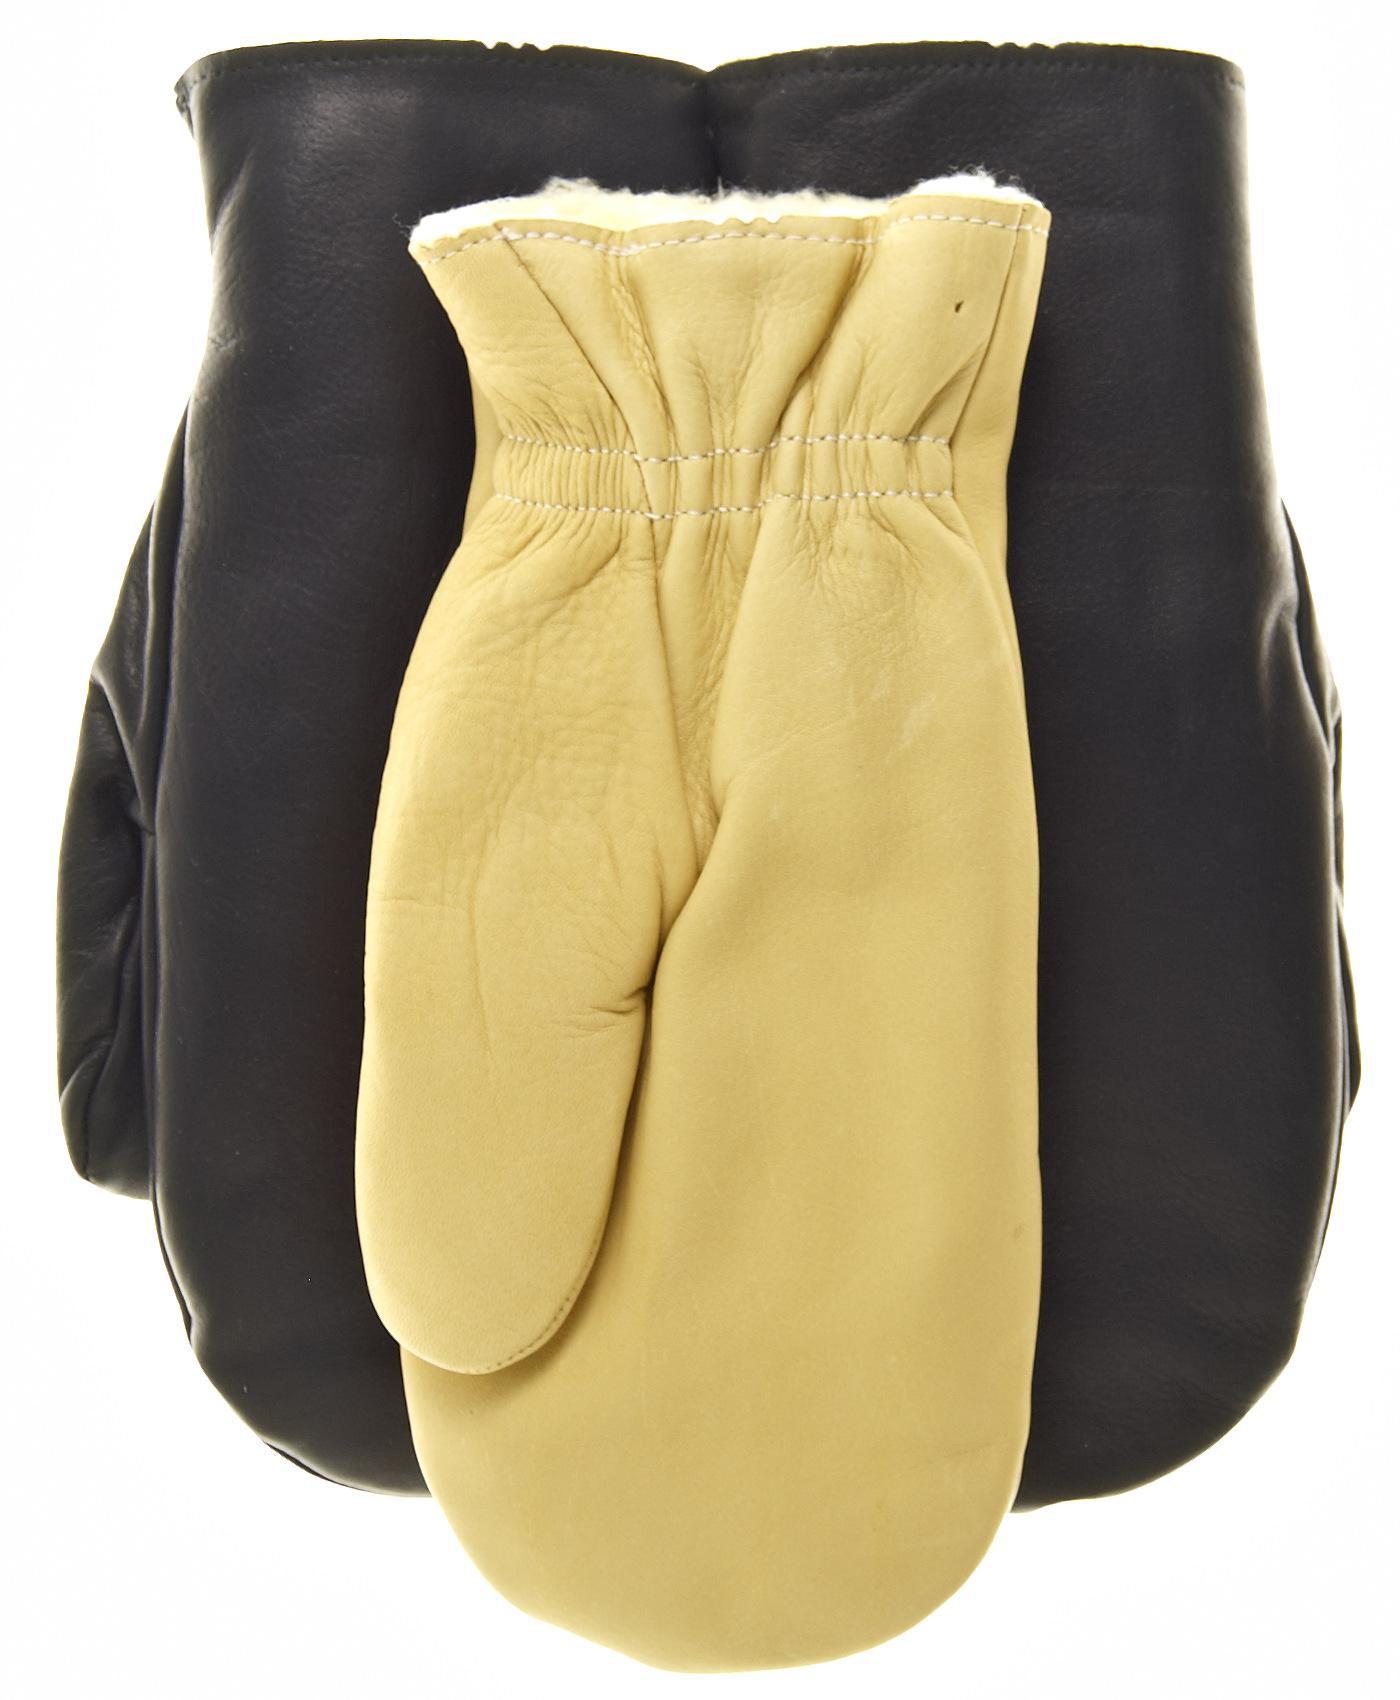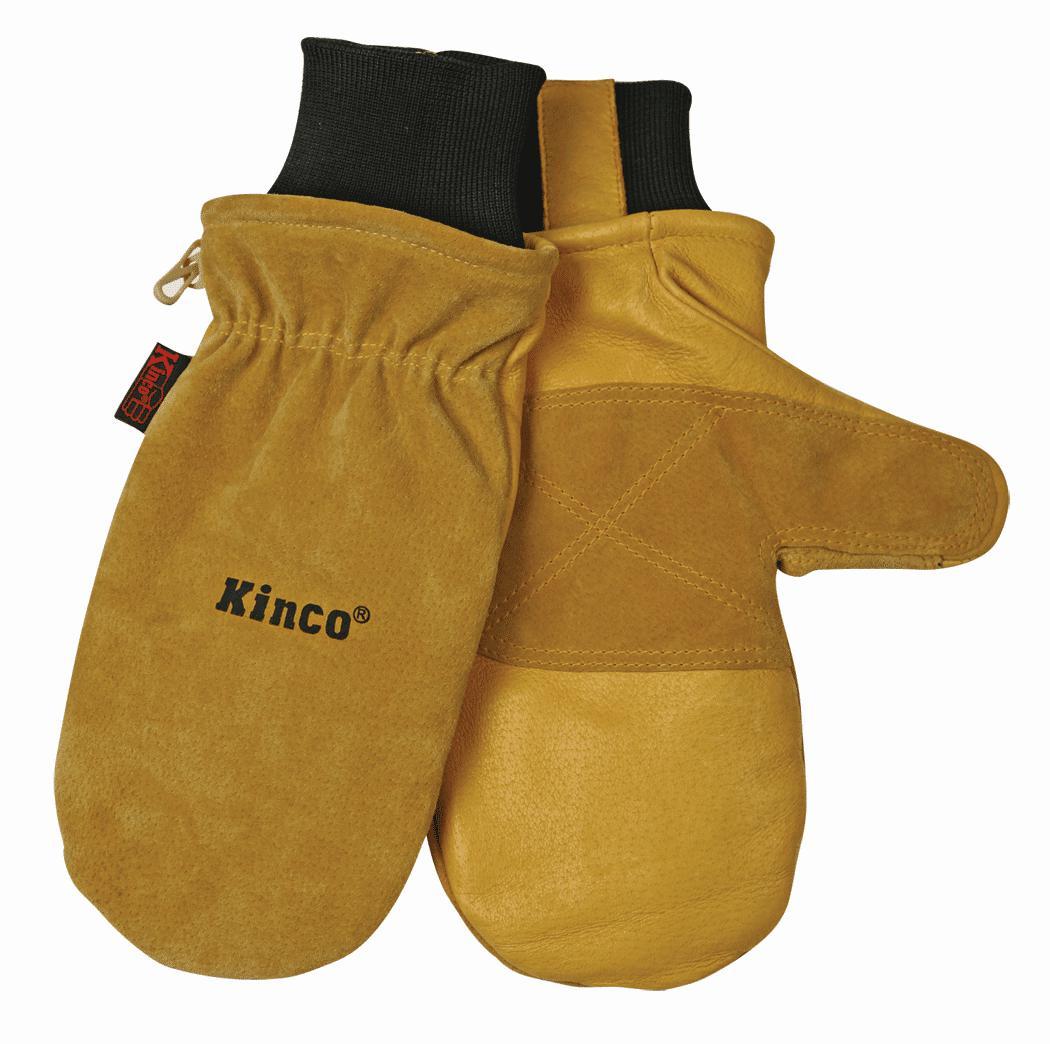The first image is the image on the left, the second image is the image on the right. For the images displayed, is the sentence "There are three mittens in the image on the left and a single pair in the image on the right." factually correct? Answer yes or no. Yes. The first image is the image on the left, the second image is the image on the right. Assess this claim about the two images: "One image shows exactly one buff beige mitten overlapping one black mitten.". Correct or not? Answer yes or no. No. 